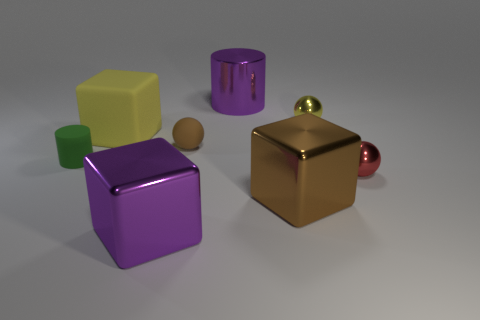There is a red metallic thing that is the same size as the green rubber cylinder; what shape is it?
Your answer should be compact. Sphere. Is the number of big purple metal cylinders less than the number of large cyan spheres?
Your response must be concise. No. How many brown rubber spheres are the same size as the purple metallic cube?
Make the answer very short. 0. There is a object that is the same color as the small rubber ball; what is its shape?
Provide a short and direct response. Cube. What material is the tiny green cylinder?
Give a very brief answer. Rubber. There is a purple shiny thing behind the small yellow thing; what size is it?
Ensure brevity in your answer.  Large. What number of small yellow metallic objects are the same shape as the tiny red object?
Provide a succinct answer. 1. What shape is the brown thing that is the same material as the tiny yellow sphere?
Provide a short and direct response. Cube. How many green things are cylinders or blocks?
Offer a terse response. 1. Are there any yellow metal things in front of the small green matte object?
Make the answer very short. No. 